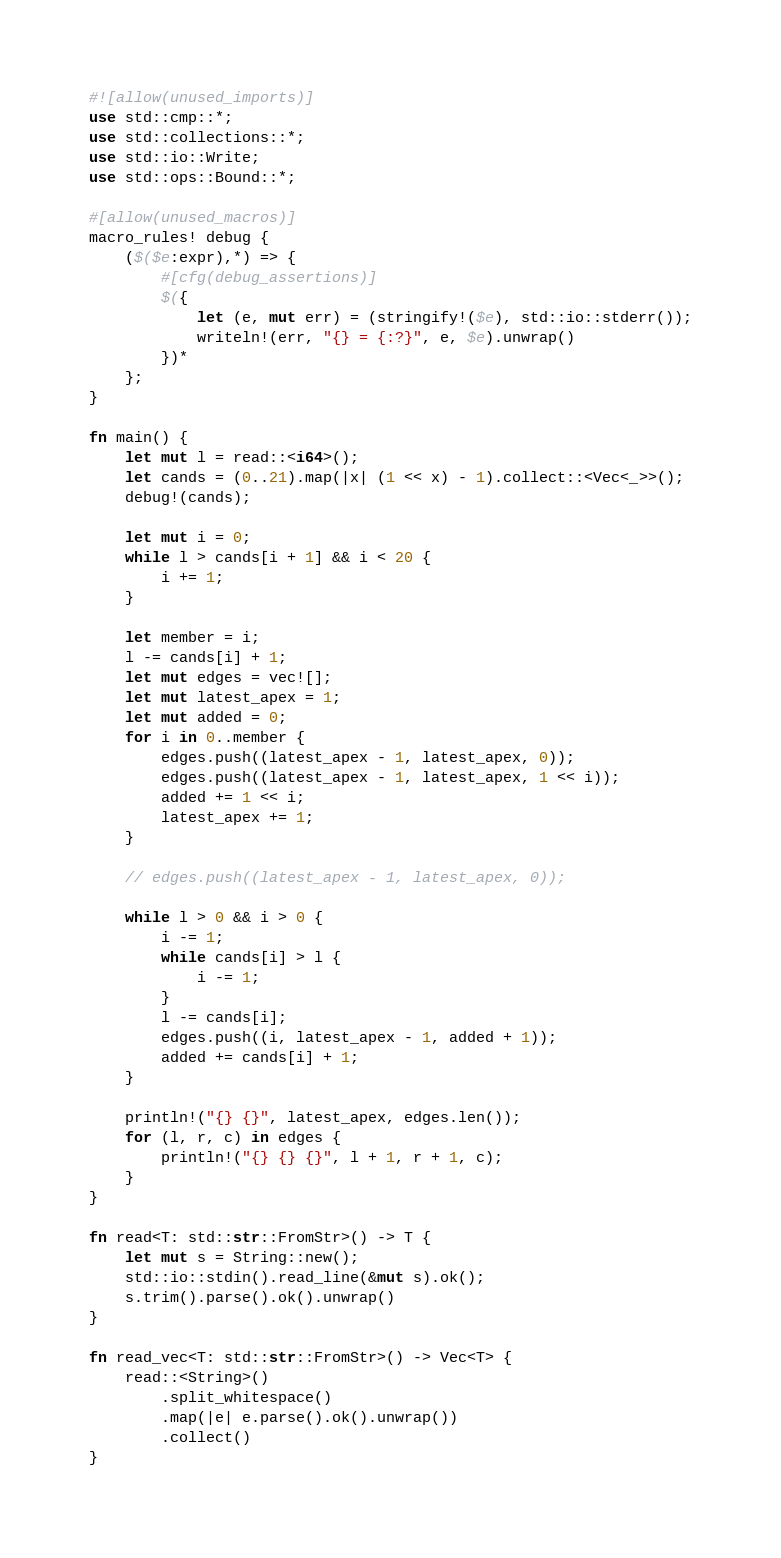Convert code to text. <code><loc_0><loc_0><loc_500><loc_500><_Rust_>#![allow(unused_imports)]
use std::cmp::*;
use std::collections::*;
use std::io::Write;
use std::ops::Bound::*;

#[allow(unused_macros)]
macro_rules! debug {
    ($($e:expr),*) => {
        #[cfg(debug_assertions)]
        $({
            let (e, mut err) = (stringify!($e), std::io::stderr());
            writeln!(err, "{} = {:?}", e, $e).unwrap()
        })*
    };
}

fn main() {
    let mut l = read::<i64>();
    let cands = (0..21).map(|x| (1 << x) - 1).collect::<Vec<_>>();
    debug!(cands);

    let mut i = 0;
    while l > cands[i + 1] && i < 20 {
        i += 1;
    }

    let member = i;
    l -= cands[i] + 1;
    let mut edges = vec![];
    let mut latest_apex = 1;
    let mut added = 0;
    for i in 0..member {
        edges.push((latest_apex - 1, latest_apex, 0));
        edges.push((latest_apex - 1, latest_apex, 1 << i));
        added += 1 << i;
        latest_apex += 1;
    }

    // edges.push((latest_apex - 1, latest_apex, 0));

    while l > 0 && i > 0 {
        i -= 1;
        while cands[i] > l {
            i -= 1;
        }
        l -= cands[i];
        edges.push((i, latest_apex - 1, added + 1));
        added += cands[i] + 1;
    }

    println!("{} {}", latest_apex, edges.len());
    for (l, r, c) in edges {
        println!("{} {} {}", l + 1, r + 1, c);
    }
}

fn read<T: std::str::FromStr>() -> T {
    let mut s = String::new();
    std::io::stdin().read_line(&mut s).ok();
    s.trim().parse().ok().unwrap()
}

fn read_vec<T: std::str::FromStr>() -> Vec<T> {
    read::<String>()
        .split_whitespace()
        .map(|e| e.parse().ok().unwrap())
        .collect()
}
</code> 